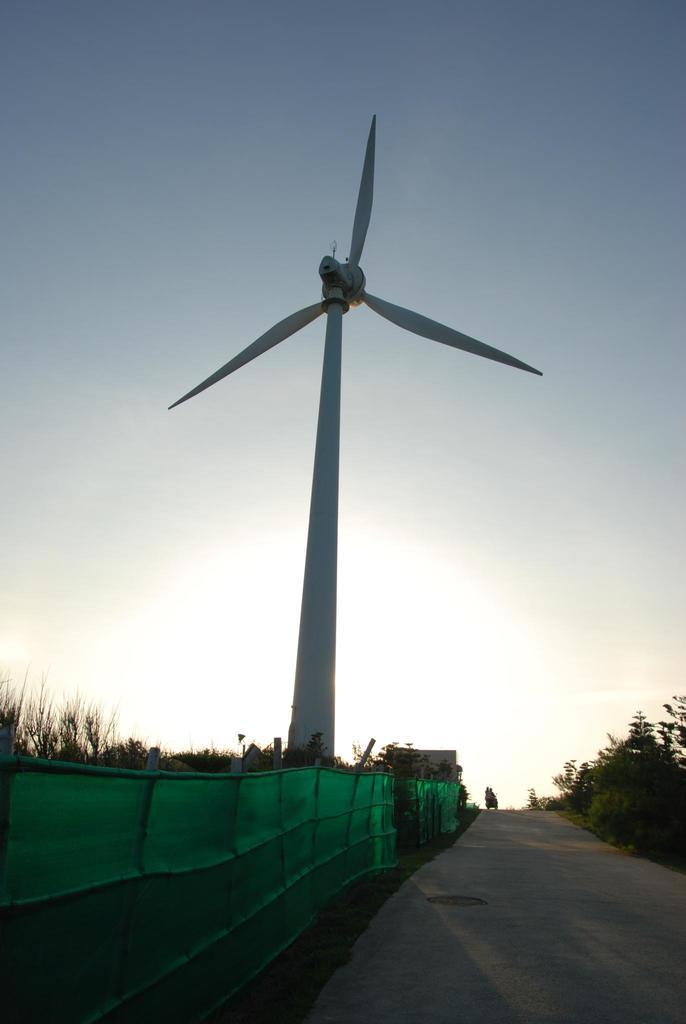What is the main feature of the image? There is a road in the image. What can be seen near the road? Fencing and trees are visible near the road. What is located in the background of the image? There is a windmill and the sky visible in the background of the image. How many bananas are hanging from the windmill in the image? There are no bananas present in the image; the windmill is the only object visible in the background. 